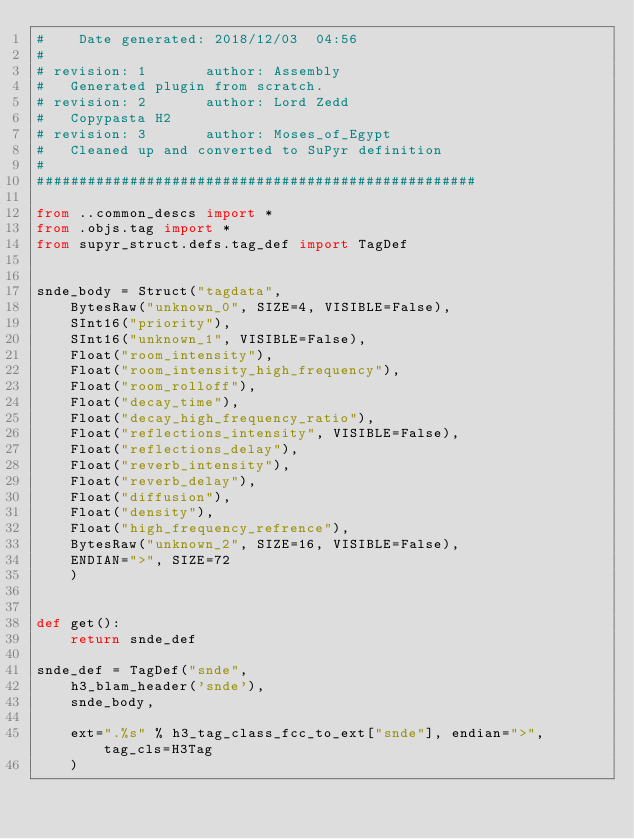<code> <loc_0><loc_0><loc_500><loc_500><_Python_>#	 Date generated: 2018/12/03  04:56
#
# revision: 1		author: Assembly
# 	Generated plugin from scratch.
# revision: 2		author: Lord Zedd
# 	Copypasta H2
# revision: 3		author: Moses_of_Egypt
# 	Cleaned up and converted to SuPyr definition
#
####################################################

from ..common_descs import *
from .objs.tag import *
from supyr_struct.defs.tag_def import TagDef


snde_body = Struct("tagdata", 
    BytesRaw("unknown_0", SIZE=4, VISIBLE=False),
    SInt16("priority"),
    SInt16("unknown_1", VISIBLE=False),
    Float("room_intensity"),
    Float("room_intensity_high_frequency"),
    Float("room_rolloff"),
    Float("decay_time"),
    Float("decay_high_frequency_ratio"),
    Float("reflections_intensity", VISIBLE=False),
    Float("reflections_delay"),
    Float("reverb_intensity"),
    Float("reverb_delay"),
    Float("diffusion"),
    Float("density"),
    Float("high_frequency_refrence"),
    BytesRaw("unknown_2", SIZE=16, VISIBLE=False),
    ENDIAN=">", SIZE=72
    )


def get():
    return snde_def

snde_def = TagDef("snde",
    h3_blam_header('snde'),
    snde_body,

    ext=".%s" % h3_tag_class_fcc_to_ext["snde"], endian=">", tag_cls=H3Tag
    )</code> 